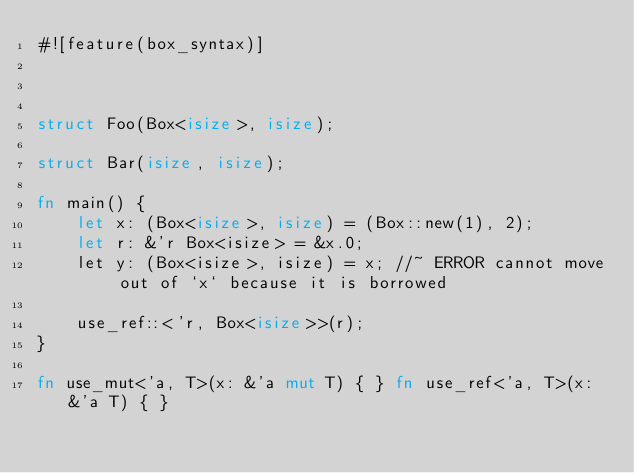Convert code to text. <code><loc_0><loc_0><loc_500><loc_500><_Rust_>#![feature(box_syntax)]



struct Foo(Box<isize>, isize);

struct Bar(isize, isize);

fn main() {
    let x: (Box<isize>, isize) = (Box::new(1), 2);
    let r: &'r Box<isize> = &x.0;
    let y: (Box<isize>, isize) = x; //~ ERROR cannot move out of `x` because it is borrowed

    use_ref::<'r, Box<isize>>(r);
}

fn use_mut<'a, T>(x: &'a mut T) { } fn use_ref<'a, T>(x: &'a T) { }
</code> 